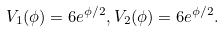<formula> <loc_0><loc_0><loc_500><loc_500>V _ { 1 } ( \phi ) = 6 e ^ { \phi / 2 } , V _ { 2 } ( \phi ) = 6 e ^ { \phi / 2 } . \,</formula> 